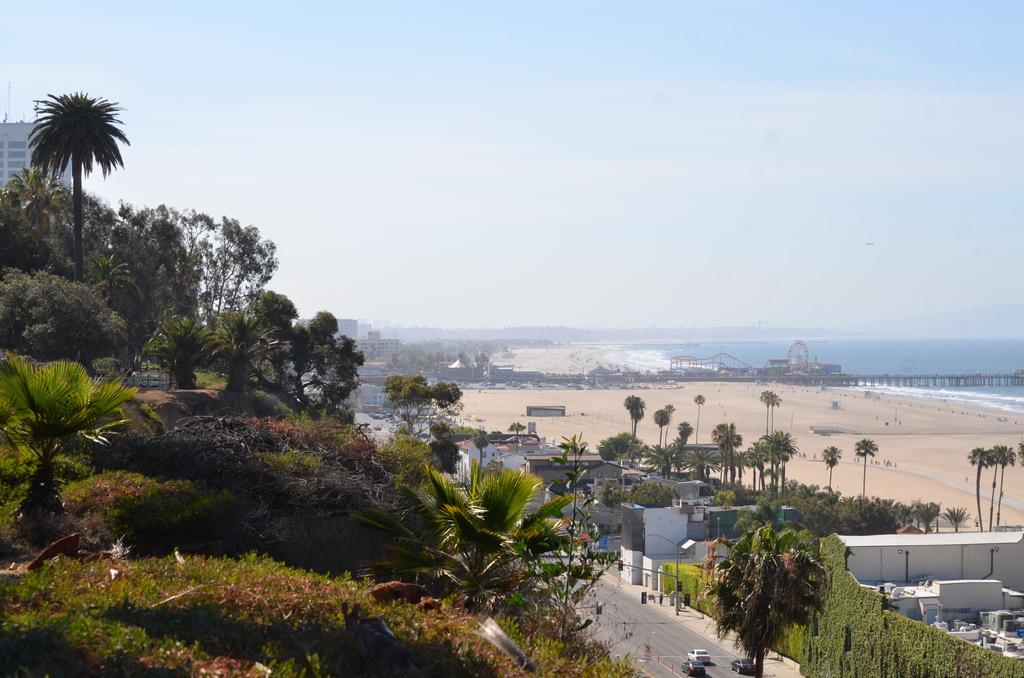What type of natural elements can be seen in the image? There are trees and plants visible in the image. What man-made structures can be seen in the image? There are vehicles on the road, buildings, a pole, and a Ferris wheel visible in the image. What type of surface is visible in the image? There is ground visible in the image. What can be seen in the background of the image? In the background of the image, there is a bridge, a Ferris wheel, and the sky. Are there any objects visible in the background of the image? Yes, there are objects visible in the background of the image, including the bridge and Ferris wheel. What type of force is being applied to the trees in the image? There is no indication of any force being applied to the trees in the image. What type of hope can be seen in the image? There is no specific hope depicted in the image; it is a scene featuring trees, plants, vehicles, buildings, a pole, ground, bridge, Ferris wheel, and the sky. 